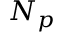<formula> <loc_0><loc_0><loc_500><loc_500>N _ { p }</formula> 